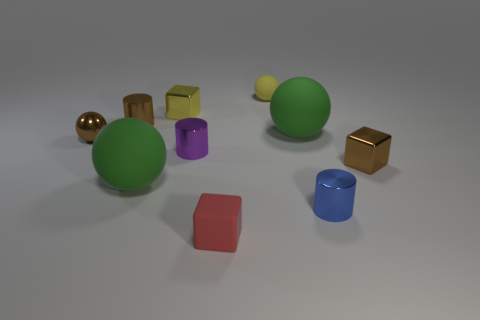Subtract all purple metal cylinders. How many cylinders are left? 2 Subtract 1 cubes. How many cubes are left? 2 Subtract all purple cylinders. How many cylinders are left? 2 Subtract all cylinders. How many objects are left? 7 Subtract all yellow cubes. Subtract all yellow cylinders. How many cubes are left? 2 Subtract all yellow balls. How many brown blocks are left? 1 Subtract all brown metal balls. Subtract all rubber things. How many objects are left? 5 Add 8 small yellow matte balls. How many small yellow matte balls are left? 9 Add 3 large green spheres. How many large green spheres exist? 5 Subtract 0 purple balls. How many objects are left? 10 